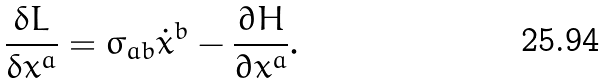<formula> <loc_0><loc_0><loc_500><loc_500>\frac { \delta L } { \delta x ^ { a } } = \sigma _ { a b } { \dot { x } } ^ { b } - \frac { \partial H } { \partial x ^ { a } } .</formula> 